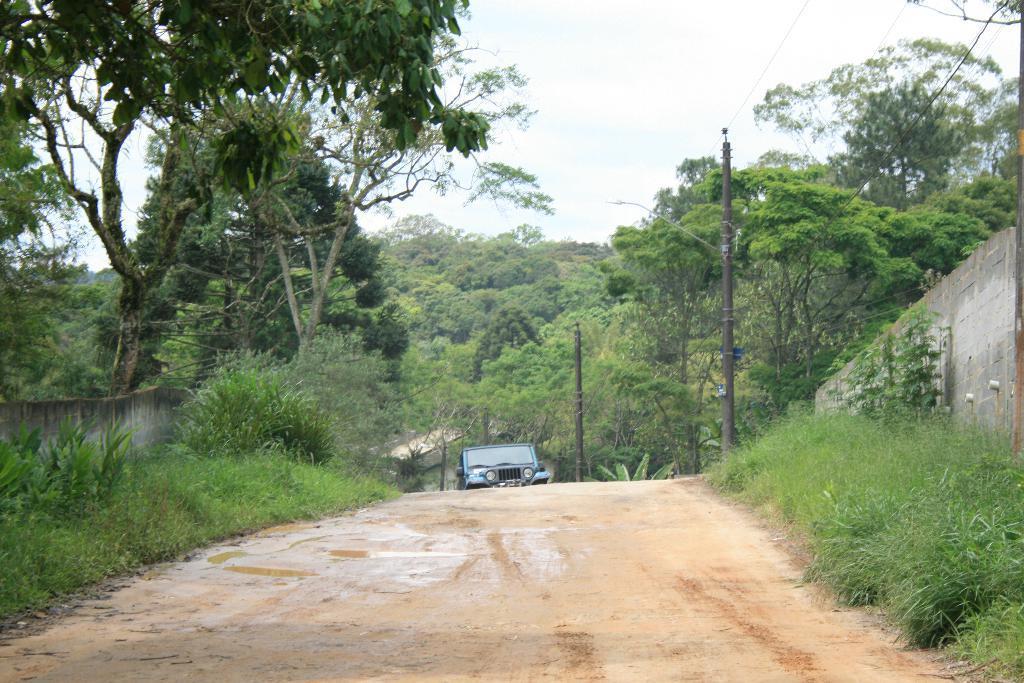Please provide a concise description of this image. In this image we can see two walls, one object looks like a house in the background, one path, two objects attached to the wall on the right side of the image, some objects attached to the pole, three poles, few wires, some wetland, one vehicle in the middle of the image, some trees in the background, it looks like some dried leaves on the ground on the left side of the image, some plants, bushes and grass on the ground. At the top there is the sky. 